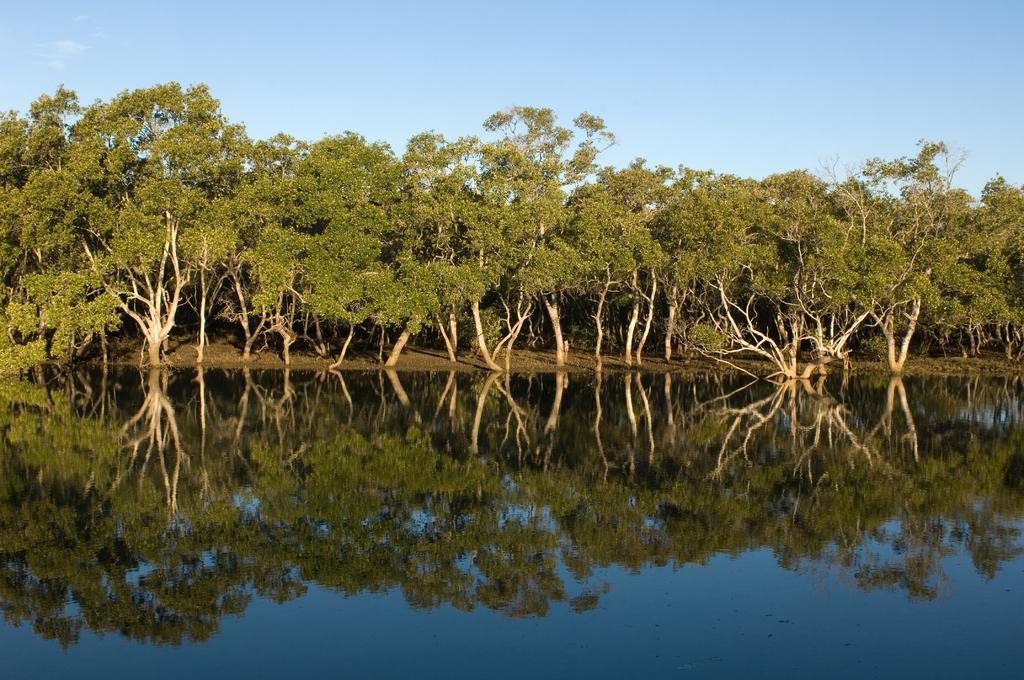Please provide a concise description of this image. As we can see in the image there are trees. There is water and at the top there is sky. 